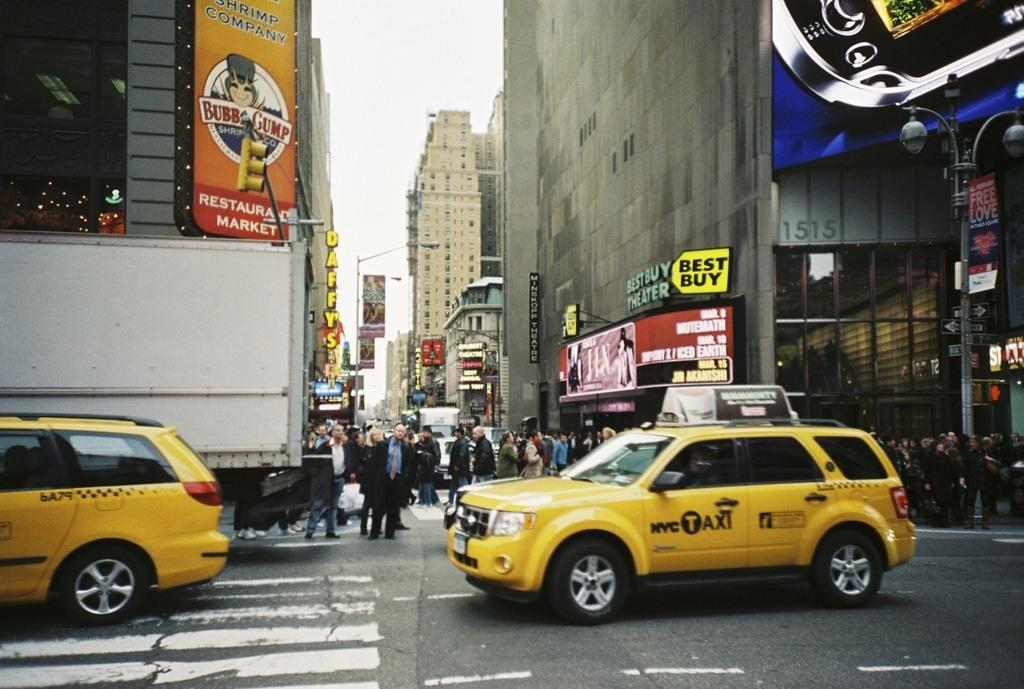Provide a one-sentence caption for the provided image. a car that has the word taxi on the side of it. 